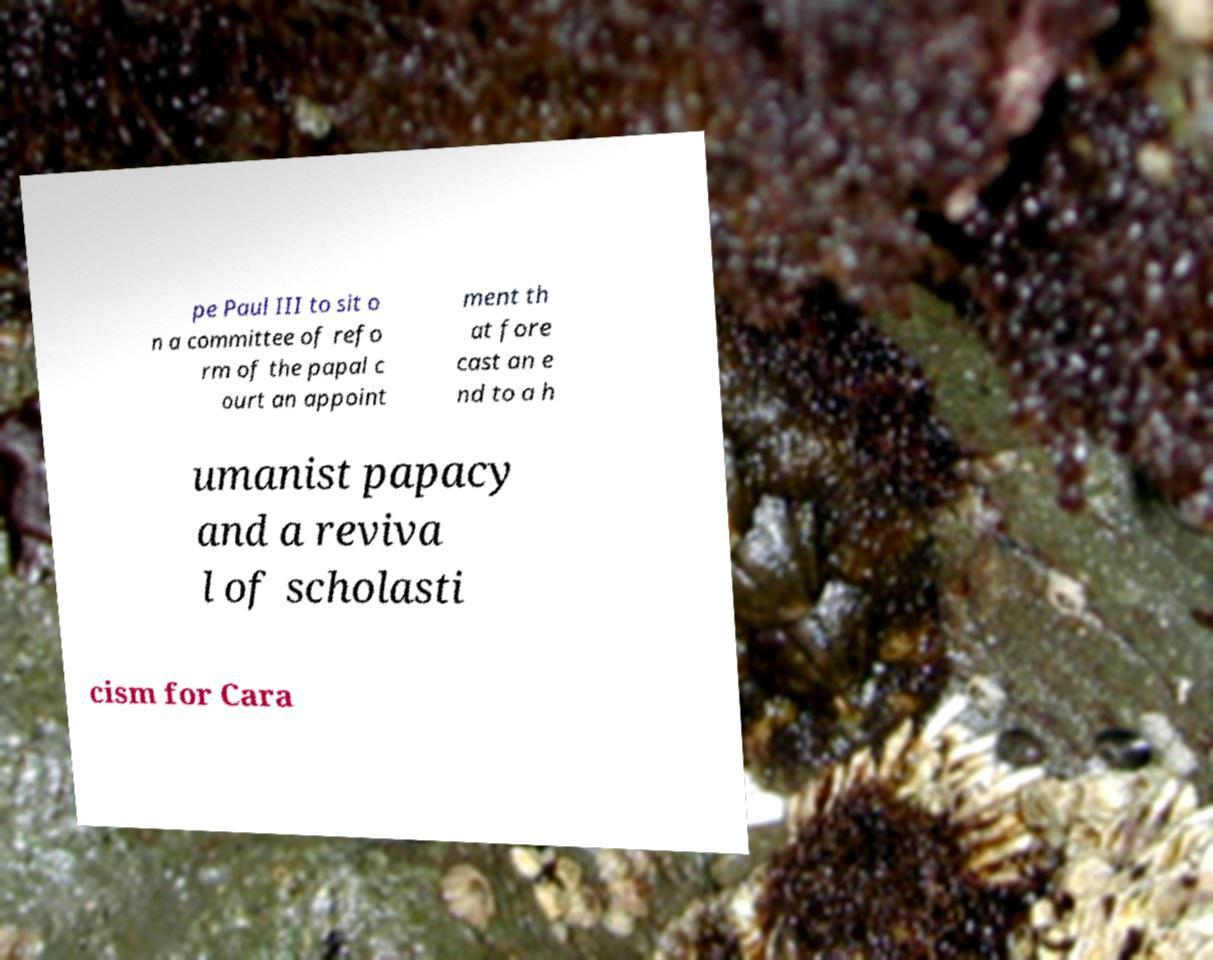Can you accurately transcribe the text from the provided image for me? pe Paul III to sit o n a committee of refo rm of the papal c ourt an appoint ment th at fore cast an e nd to a h umanist papacy and a reviva l of scholasti cism for Cara 